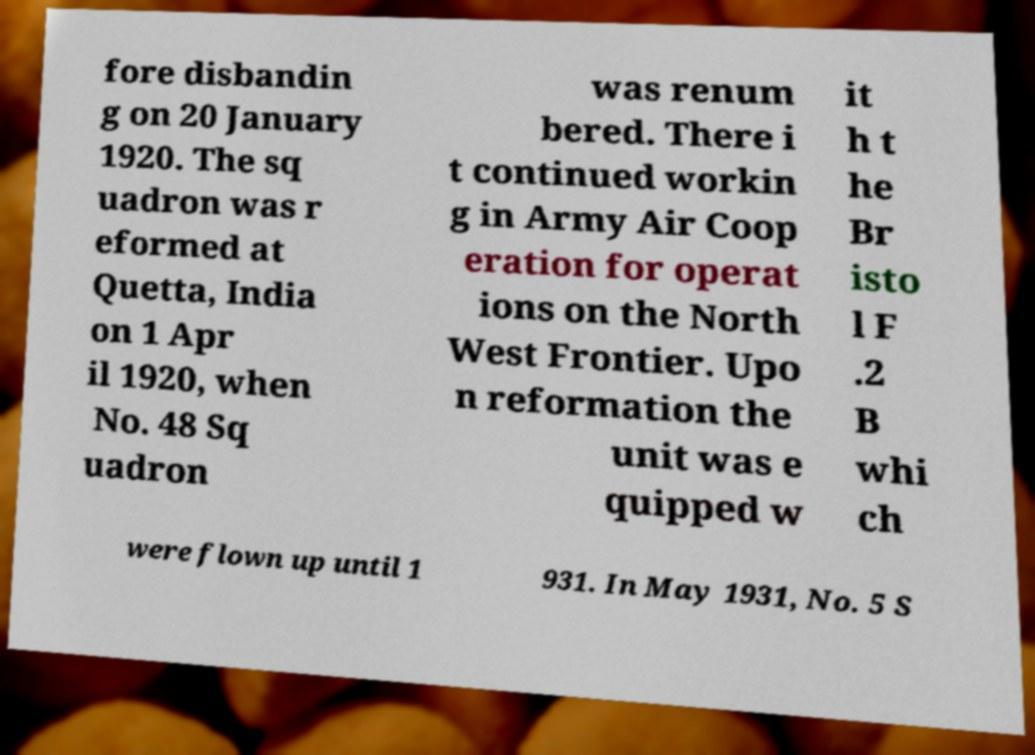Can you read and provide the text displayed in the image?This photo seems to have some interesting text. Can you extract and type it out for me? fore disbandin g on 20 January 1920. The sq uadron was r eformed at Quetta, India on 1 Apr il 1920, when No. 48 Sq uadron was renum bered. There i t continued workin g in Army Air Coop eration for operat ions on the North West Frontier. Upo n reformation the unit was e quipped w it h t he Br isto l F .2 B whi ch were flown up until 1 931. In May 1931, No. 5 S 